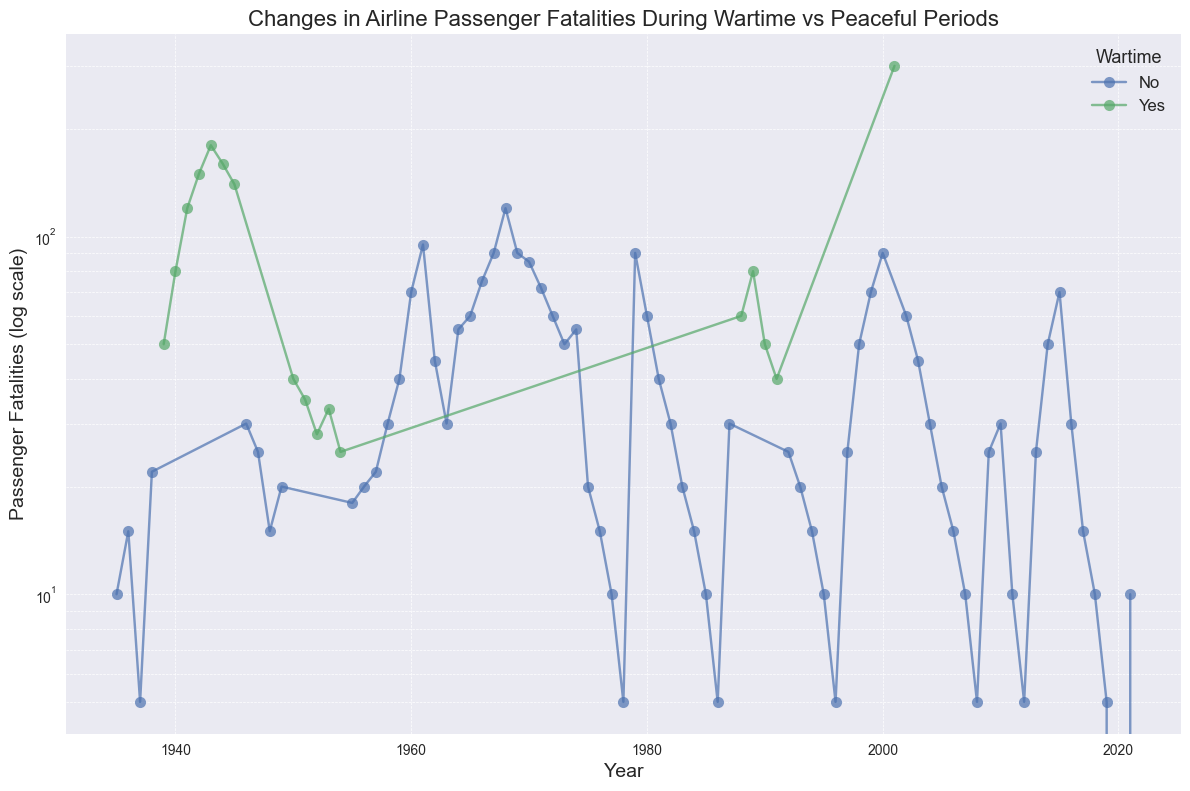What years showed a significant spike in passenger fatalities during wartime? By observing the sharp increase in passenger fatalities during certain years in the wartime series, the noticeable spikes are in 1939, 1940, 1941, and 2001, indicated by a steep rise.
Answer: 1939, 1940, 1941, 2001 During which wartime period did passenger fatalities peak? By comparing the peak values for each wartime period on the log scale, we see that the highest visual peak occurs in 1943.
Answer: 1943 Which peacetime year had the highest number of passenger fatalities? By looking at the peak values during peacetime periods, 2001 shows the highest number of passenger fatalities.
Answer: 2001 How did the trend of passenger fatalities change before and after 1945? The fatalities show a general decrease after 1945 compared to the steep increase before 1945, as seen by the overall downward trend and fewer peaks.
Answer: Decreased after 1945 Are there years where peace and wartime fatalities appear to overlap in values? Comparing the wartime values with the peacetime trend visually, certain peace years (like 1960, 1961) have fatalities similar to lower wartime peaks (like 1950-1951).
Answer: Yes, 1960, 1961 What's the median value of passenger fatalities during wartime periods? To find the median, we need the wartime fatalities sorted: [25, 28, 30, 33, 35, 40, 40, 50, 50, 80, 80, 120, 140, 150, 160, 180, 300]. The median value is the middle number (80).
Answer: 80 Which period (wartime or peacetime) shows more variability in passenger fatalities? By observing the spread and variance of data points, wartime periods show higher peaks and more fluctuation in values compared to a more stable trend in peacetime periods.
Answer: Wartime Do the years 1980-1985 show an increasing or decreasing trend in fatalities during peacetime? Observing the markers in those years, there is a visible decrease in the log scale values, showing a downward trend.
Answer: Decreasing What is the impact of World War II on airline passenger fatalities? World War II years (1939-1945) show a dramatic increase in fatalities, peaking in 1943 and then declining after the war period.
Answer: Increased, peaking in 1943 How often did peacetime fatalities fall below 10 after 1975? Reference visual points for years after 1975 show values below 10 for 1977, 1978, 1985, 1986, 2008, 2012, 2019.
Answer: 7 times 